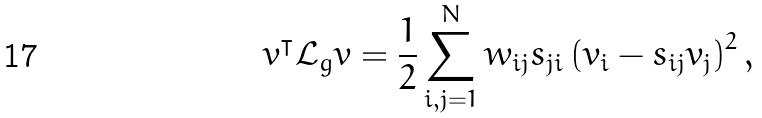Convert formula to latex. <formula><loc_0><loc_0><loc_500><loc_500>v ^ { \intercal } \mathcal { L } _ { g } v = \frac { 1 } { 2 } \sum _ { i , j = 1 } ^ { N } w _ { i j } s _ { j i } \left ( v _ { i } - s _ { i j } v _ { j } \right ) ^ { 2 } ,</formula> 